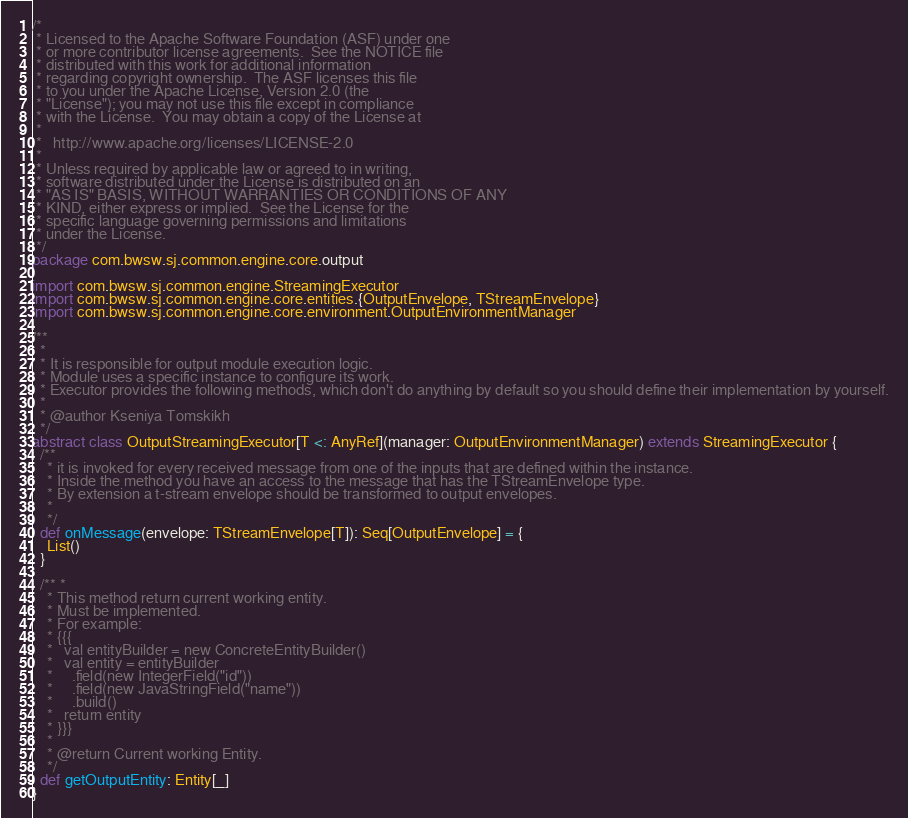Convert code to text. <code><loc_0><loc_0><loc_500><loc_500><_Scala_>/*
 * Licensed to the Apache Software Foundation (ASF) under one
 * or more contributor license agreements.  See the NOTICE file
 * distributed with this work for additional information
 * regarding copyright ownership.  The ASF licenses this file
 * to you under the Apache License, Version 2.0 (the
 * "License"); you may not use this file except in compliance
 * with the License.  You may obtain a copy of the License at
 *
 *   http://www.apache.org/licenses/LICENSE-2.0
 *
 * Unless required by applicable law or agreed to in writing,
 * software distributed under the License is distributed on an
 * "AS IS" BASIS, WITHOUT WARRANTIES OR CONDITIONS OF ANY
 * KIND, either express or implied.  See the License for the
 * specific language governing permissions and limitations
 * under the License.
 */
package com.bwsw.sj.common.engine.core.output

import com.bwsw.sj.common.engine.StreamingExecutor
import com.bwsw.sj.common.engine.core.entities.{OutputEnvelope, TStreamEnvelope}
import com.bwsw.sj.common.engine.core.environment.OutputEnvironmentManager

/**
  *
  * It is responsible for output module execution logic.
  * Module uses a specific instance to configure its work.
  * Executor provides the following methods, which don't do anything by default so you should define their implementation by yourself.
  *
  * @author Kseniya Tomskikh
  */
abstract class OutputStreamingExecutor[T <: AnyRef](manager: OutputEnvironmentManager) extends StreamingExecutor {
  /**
    * it is invoked for every received message from one of the inputs that are defined within the instance.
    * Inside the method you have an access to the message that has the TStreamEnvelope type.
    * By extension a t-stream envelope should be transformed to output envelopes.
    *
    */
  def onMessage(envelope: TStreamEnvelope[T]): Seq[OutputEnvelope] = {
    List()
  }

  /** *
    * This method return current working entity.
    * Must be implemented.
    * For example:
    * {{{
    *   val entityBuilder = new ConcreteEntityBuilder()
    *   val entity = entityBuilder
    *     .field(new IntegerField("id"))
    *     .field(new JavaStringField("name"))
    *     .build()
    *   return entity
    * }}}
    *
    * @return Current working Entity.
    */
  def getOutputEntity: Entity[_]
}
</code> 